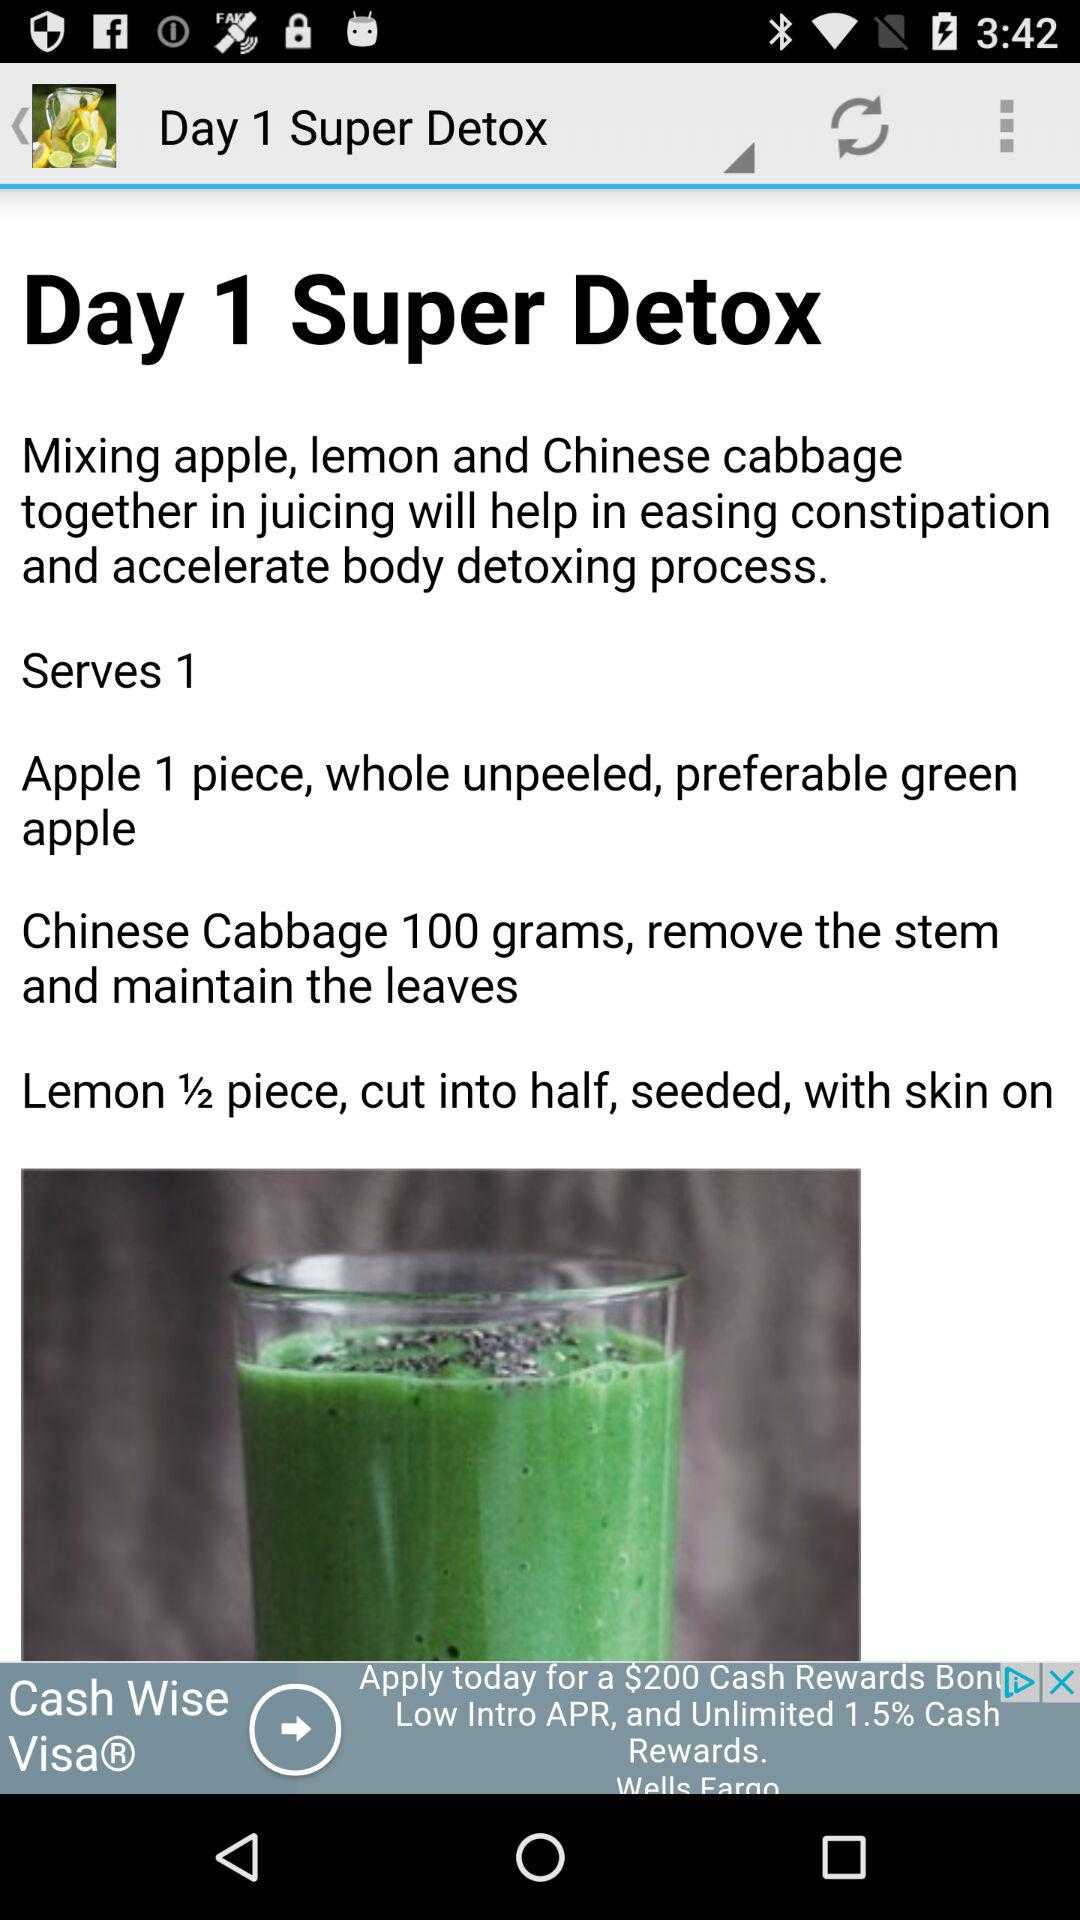What are the ingredients used to prepare "Super Detox"? The ingredients used to prepare "Super Detox" are "apple", "lemon" and "Chinese cabbage". 